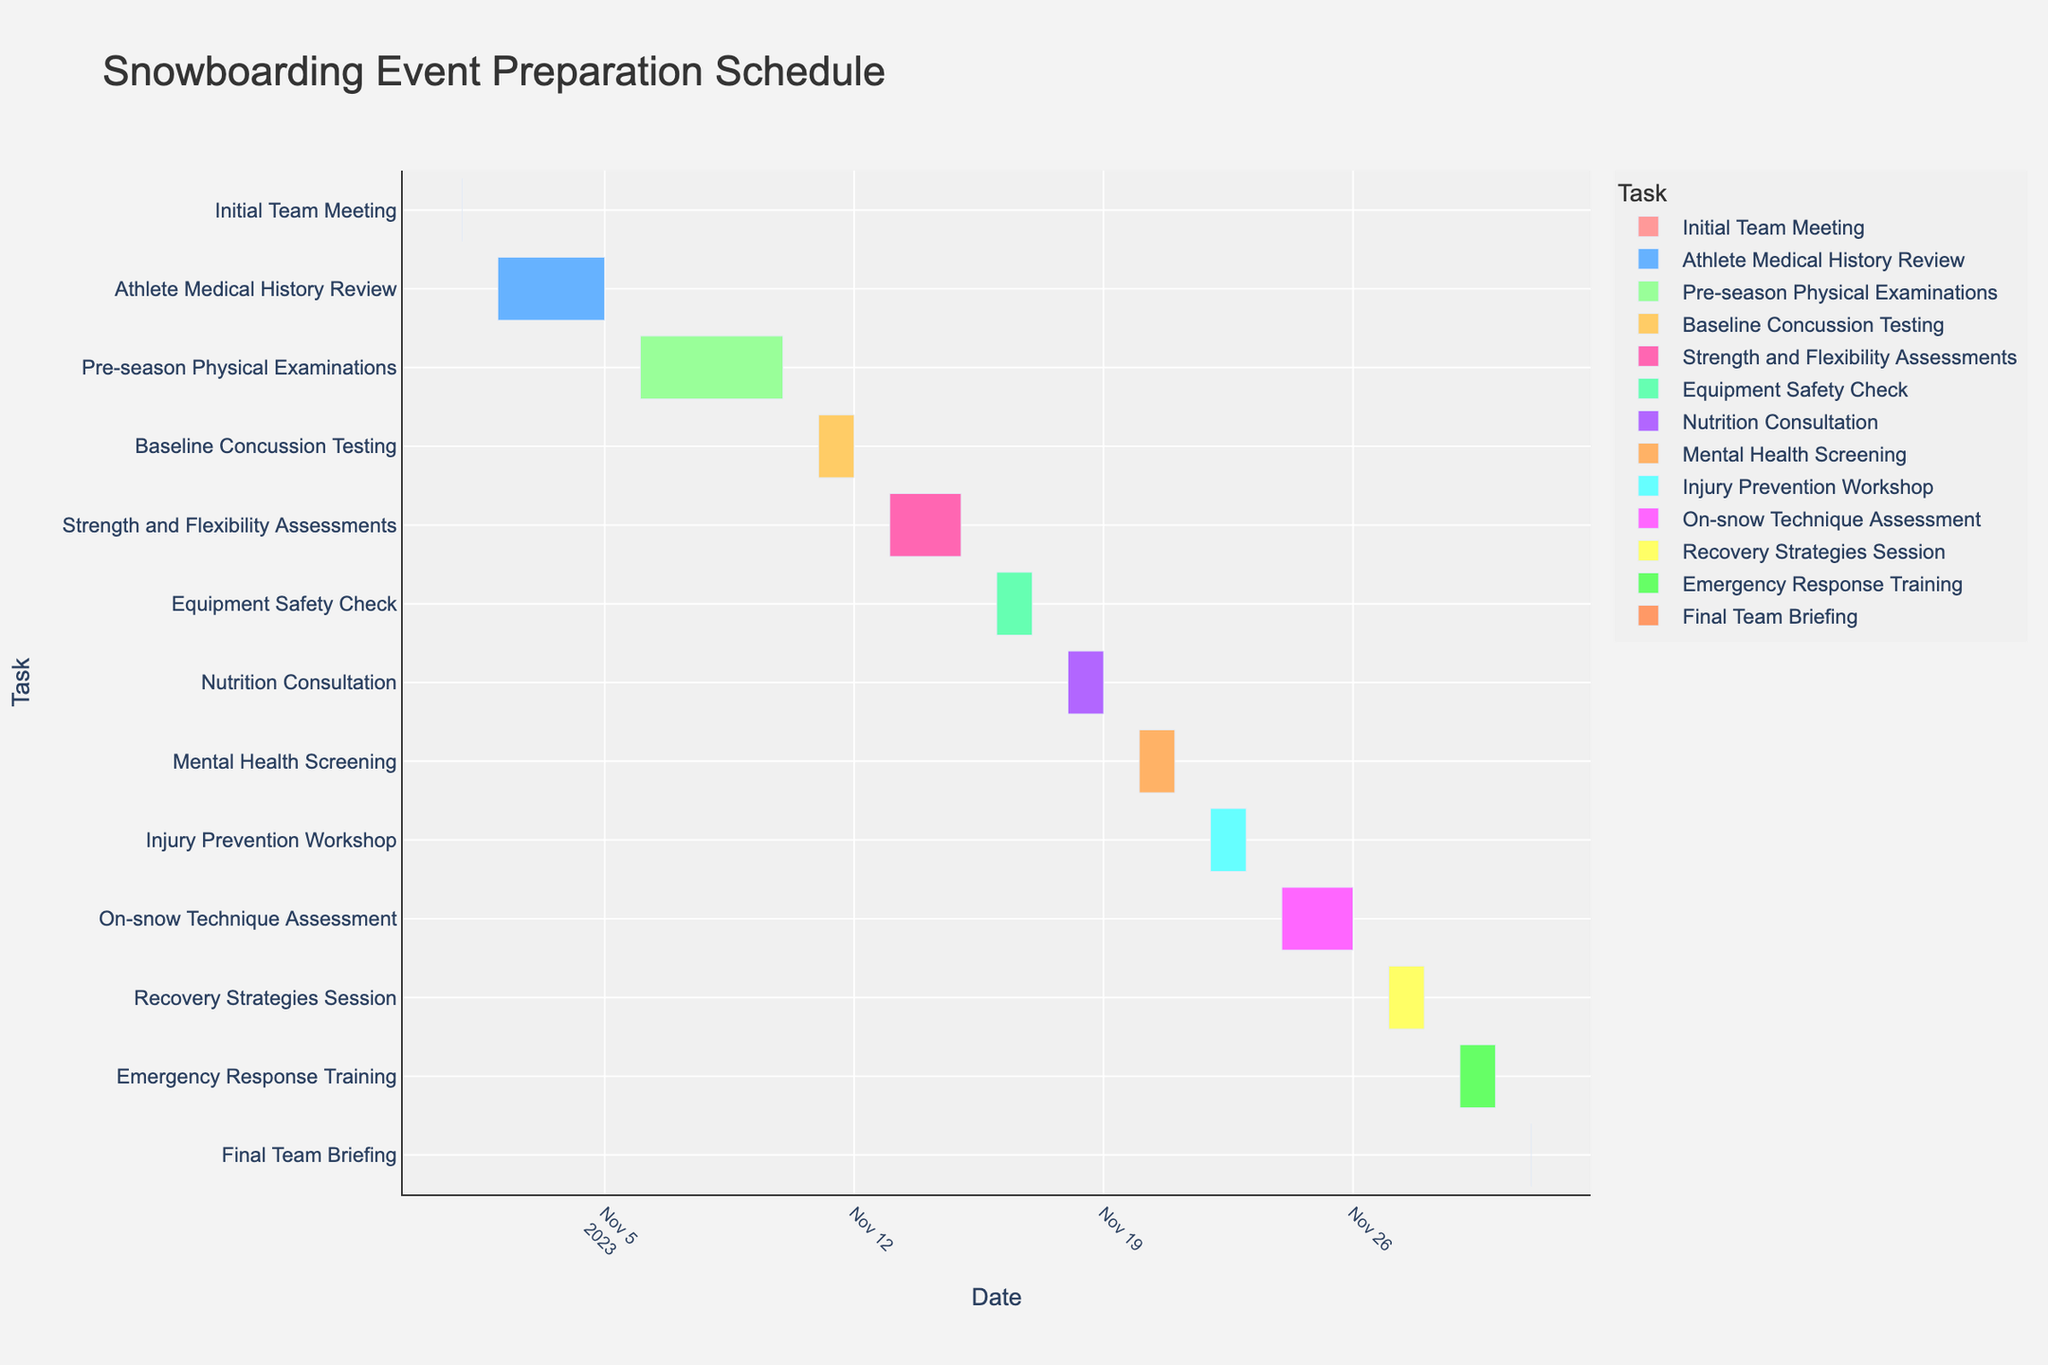What is the title of the Gantt chart? The title is located at the top of the Gantt chart, indicating the overall content of the chart.
Answer: Snowboarding Event Preparation Schedule When does the "Baseline Concussion Testing" begin and end? "Baseline Concussion Testing" is one of the tasks. Check the start and end dates beside this task on the left side of the chart.
Answer: Start: 2023-11-11, End: 2023-11-12 How many days is the "Pre-season Physical Examinations" scheduled to last? The duration of each task is usually shown in the chart next to each task name. Look for the duration beside the "Pre-season Physical Examinations" task.
Answer: 5 days Which task immediately follows the "Strength and Flexibility Assessments"? Tasks are displayed in chronological order from top to bottom. Find the task listed immediately after "Strength and Flexibility Assessments".
Answer: Equipment Safety Check How long is the "Emergency Response Training" compared to the "Final Team Briefing"? Determine the durations of both tasks as depicted in the chart and calculate the difference in days.
Answer: Emergency Response Training is 1 day longer What is the combined duration of the "Initial Team Meeting" and "Final Team Briefing"? Sum the durations of both tasks as portrayed in the chart.
Answer: 2 days Which task takes place immediately before the "On-snow Technique Assessment"? Identify the task listed just above the "On-snow Technique Assessment" in the chronological sequence.
Answer: Injury Prevention Workshop Which has a longer duration: "Nutrition Consultation" or "Mental Health Screening"? Compare the durations of the two tasks shown in the chart.
Answer: Both are the same duration How many tasks begin on the same day as "Initial Team Meeting"? Check which other tasks, if any, start on the same date as the "Initial Team Meeting".
Answer: 0 tasks Which color is associated with the "Recovery Strategies Session"? The color assigned to each task is indicated next to the task names. Locate the color for the "Recovery Strategies Session".
Answer: Yellow 